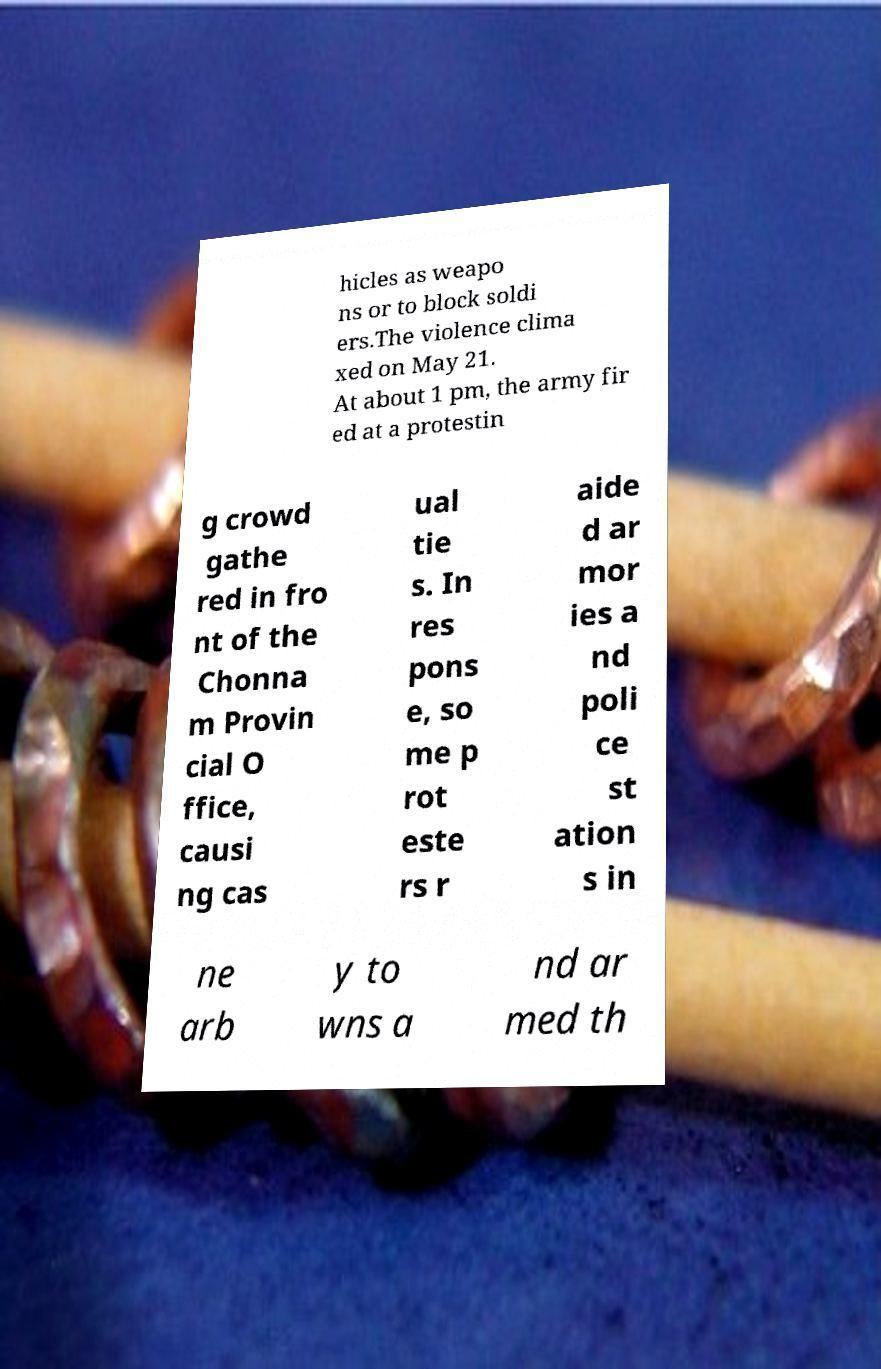I need the written content from this picture converted into text. Can you do that? hicles as weapo ns or to block soldi ers.The violence clima xed on May 21. At about 1 pm, the army fir ed at a protestin g crowd gathe red in fro nt of the Chonna m Provin cial O ffice, causi ng cas ual tie s. In res pons e, so me p rot este rs r aide d ar mor ies a nd poli ce st ation s in ne arb y to wns a nd ar med th 